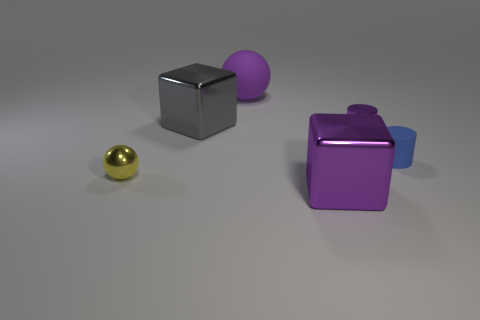Are there any tiny shiny things to the left of the large object that is to the left of the large purple sphere?
Your answer should be very brief. Yes. Is the number of yellow metallic balls less than the number of big metal things?
Keep it short and to the point. Yes. How many other small blue matte things are the same shape as the blue object?
Offer a terse response. 0. What number of green objects are large rubber things or metal things?
Give a very brief answer. 0. There is a cube behind the small metal object that is left of the tiny purple cylinder; what size is it?
Keep it short and to the point. Large. There is a big purple object that is the same shape as the tiny yellow object; what is it made of?
Keep it short and to the point. Rubber. What number of gray cylinders are the same size as the blue object?
Provide a short and direct response. 0. Does the blue cylinder have the same size as the metallic cylinder?
Keep it short and to the point. Yes. What size is the thing that is both to the right of the large gray block and behind the metal cylinder?
Provide a succinct answer. Large. Are there more gray metallic things that are behind the purple sphere than big metal things on the left side of the big gray metallic object?
Keep it short and to the point. No. 